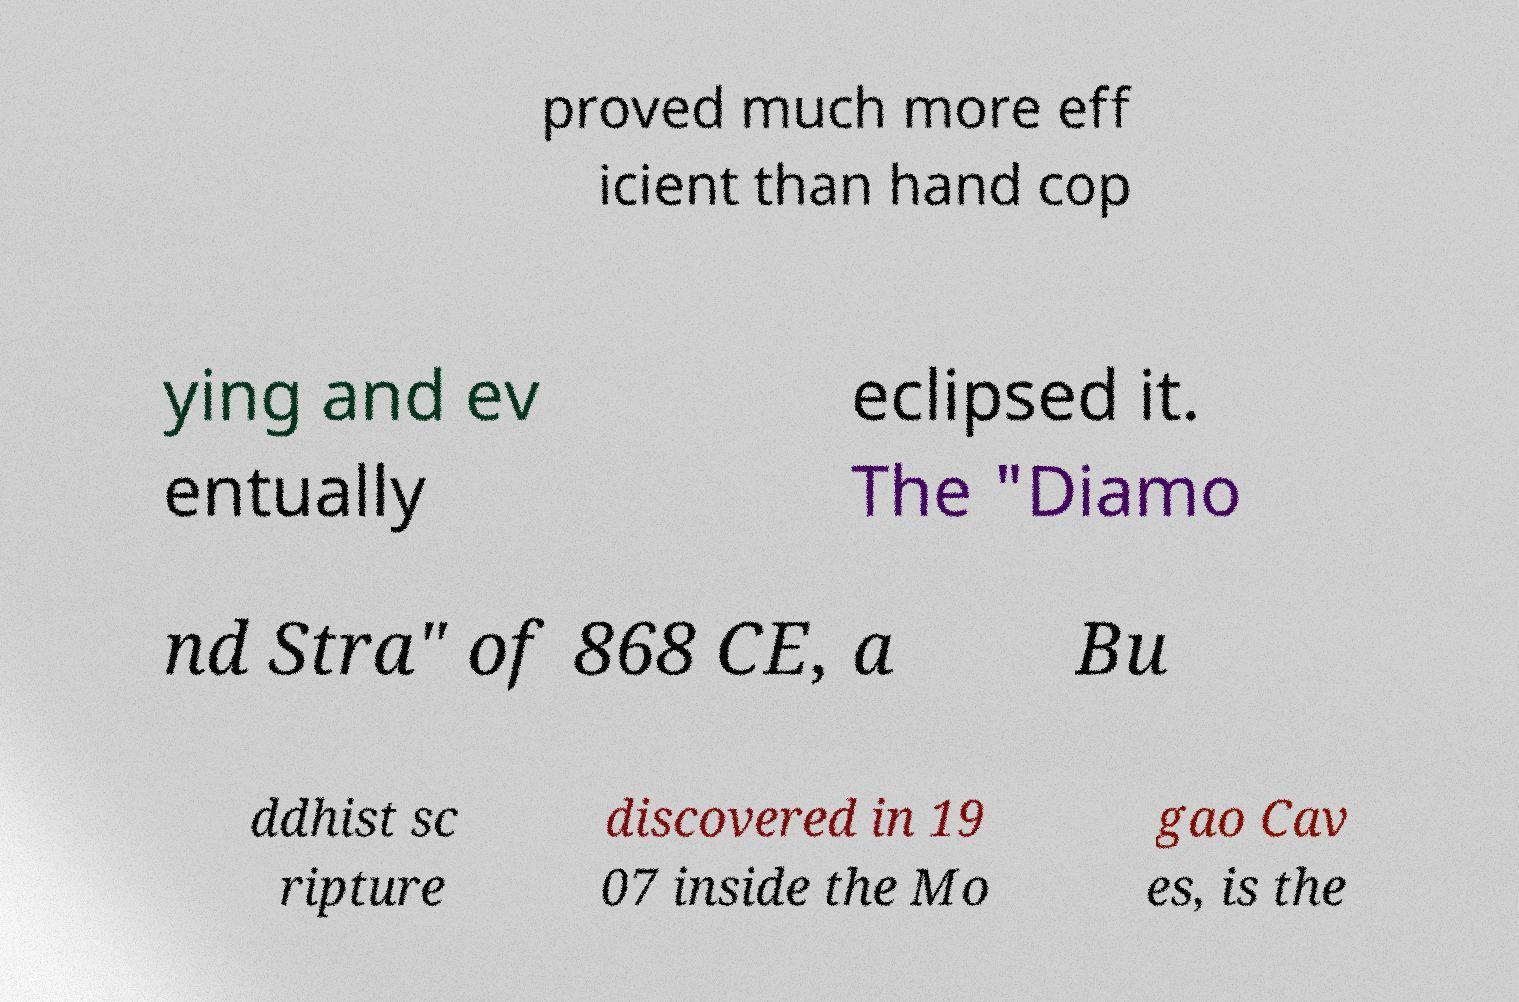Could you assist in decoding the text presented in this image and type it out clearly? proved much more eff icient than hand cop ying and ev entually eclipsed it. The "Diamo nd Stra" of 868 CE, a Bu ddhist sc ripture discovered in 19 07 inside the Mo gao Cav es, is the 